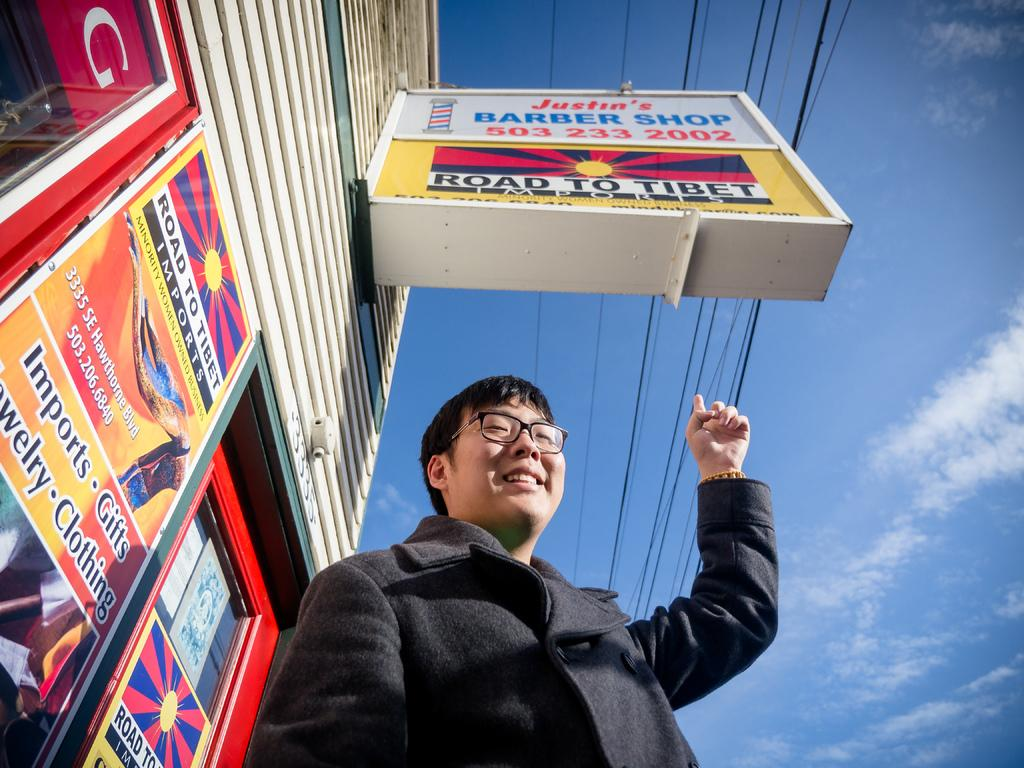<image>
Share a concise interpretation of the image provided. An Asian man on the street points to a sign that says Road to Tibet. 